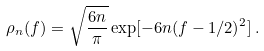<formula> <loc_0><loc_0><loc_500><loc_500>\rho _ { n } ( f ) = \sqrt { \frac { 6 n } { \pi } } \exp [ - 6 n ( f - 1 / 2 ) ^ { 2 } ] \, .</formula> 